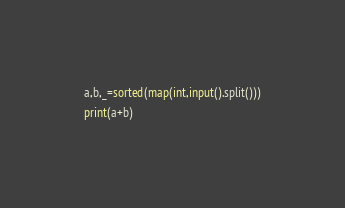Convert code to text. <code><loc_0><loc_0><loc_500><loc_500><_Python_>a,b,_=sorted(map(int,input().split()))
print(a+b)</code> 